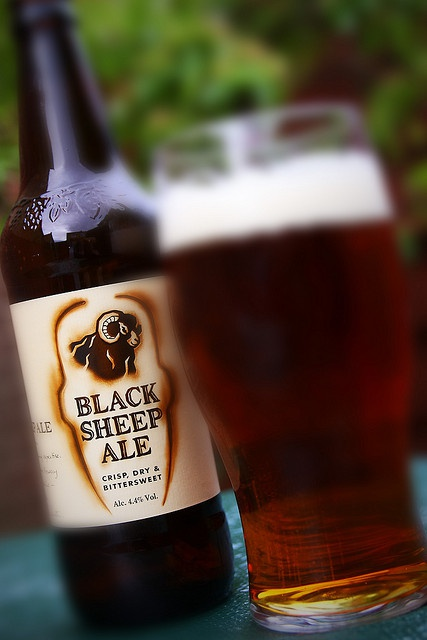Describe the objects in this image and their specific colors. I can see cup in darkgreen, black, maroon, lightgray, and gray tones, bottle in darkgreen, black, lightgray, tan, and gray tones, and dining table in darkgreen, black, maroon, teal, and blue tones in this image. 